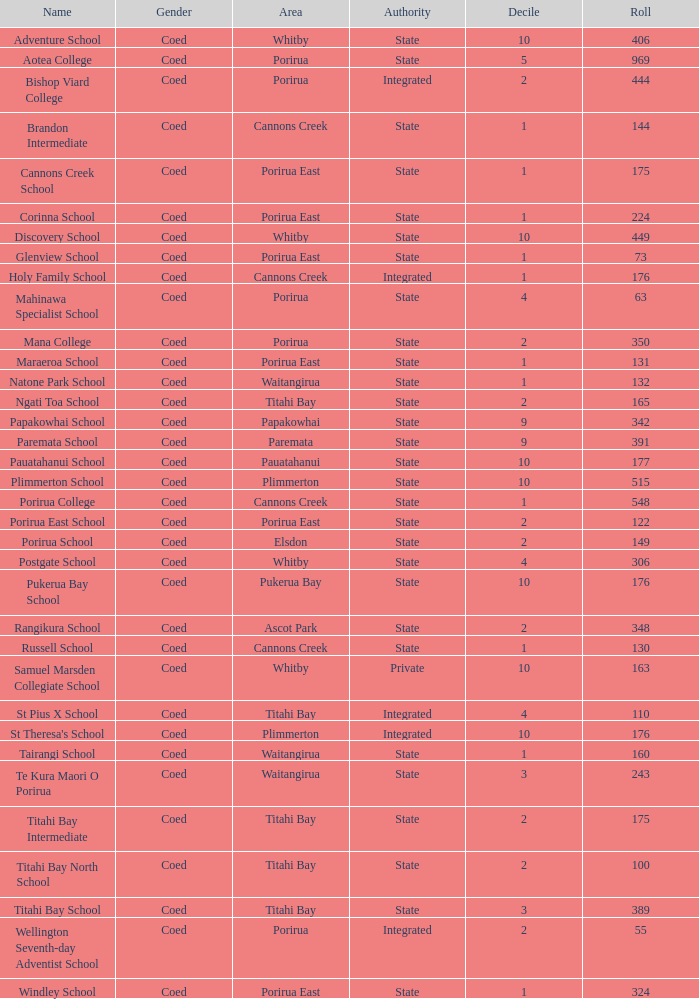Would you mind parsing the complete table? {'header': ['Name', 'Gender', 'Area', 'Authority', 'Decile', 'Roll'], 'rows': [['Adventure School', 'Coed', 'Whitby', 'State', '10', '406'], ['Aotea College', 'Coed', 'Porirua', 'State', '5', '969'], ['Bishop Viard College', 'Coed', 'Porirua', 'Integrated', '2', '444'], ['Brandon Intermediate', 'Coed', 'Cannons Creek', 'State', '1', '144'], ['Cannons Creek School', 'Coed', 'Porirua East', 'State', '1', '175'], ['Corinna School', 'Coed', 'Porirua East', 'State', '1', '224'], ['Discovery School', 'Coed', 'Whitby', 'State', '10', '449'], ['Glenview School', 'Coed', 'Porirua East', 'State', '1', '73'], ['Holy Family School', 'Coed', 'Cannons Creek', 'Integrated', '1', '176'], ['Mahinawa Specialist School', 'Coed', 'Porirua', 'State', '4', '63'], ['Mana College', 'Coed', 'Porirua', 'State', '2', '350'], ['Maraeroa School', 'Coed', 'Porirua East', 'State', '1', '131'], ['Natone Park School', 'Coed', 'Waitangirua', 'State', '1', '132'], ['Ngati Toa School', 'Coed', 'Titahi Bay', 'State', '2', '165'], ['Papakowhai School', 'Coed', 'Papakowhai', 'State', '9', '342'], ['Paremata School', 'Coed', 'Paremata', 'State', '9', '391'], ['Pauatahanui School', 'Coed', 'Pauatahanui', 'State', '10', '177'], ['Plimmerton School', 'Coed', 'Plimmerton', 'State', '10', '515'], ['Porirua College', 'Coed', 'Cannons Creek', 'State', '1', '548'], ['Porirua East School', 'Coed', 'Porirua East', 'State', '2', '122'], ['Porirua School', 'Coed', 'Elsdon', 'State', '2', '149'], ['Postgate School', 'Coed', 'Whitby', 'State', '4', '306'], ['Pukerua Bay School', 'Coed', 'Pukerua Bay', 'State', '10', '176'], ['Rangikura School', 'Coed', 'Ascot Park', 'State', '2', '348'], ['Russell School', 'Coed', 'Cannons Creek', 'State', '1', '130'], ['Samuel Marsden Collegiate School', 'Coed', 'Whitby', 'Private', '10', '163'], ['St Pius X School', 'Coed', 'Titahi Bay', 'Integrated', '4', '110'], ["St Theresa's School", 'Coed', 'Plimmerton', 'Integrated', '10', '176'], ['Tairangi School', 'Coed', 'Waitangirua', 'State', '1', '160'], ['Te Kura Maori O Porirua', 'Coed', 'Waitangirua', 'State', '3', '243'], ['Titahi Bay Intermediate', 'Coed', 'Titahi Bay', 'State', '2', '175'], ['Titahi Bay North School', 'Coed', 'Titahi Bay', 'State', '2', '100'], ['Titahi Bay School', 'Coed', 'Titahi Bay', 'State', '3', '389'], ['Wellington Seventh-day Adventist School', 'Coed', 'Porirua', 'Integrated', '2', '55'], ['Windley School', 'Coed', 'Porirua East', 'State', '1', '324']]} What integrated school had a decile of 2 and a roll larger than 55? Bishop Viard College. 